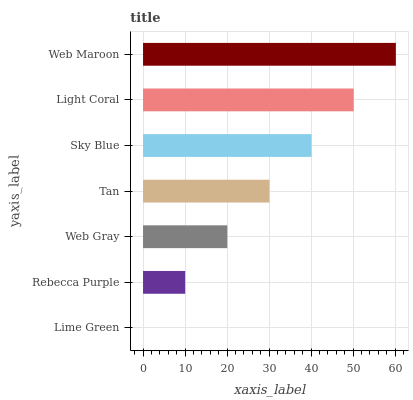Is Lime Green the minimum?
Answer yes or no. Yes. Is Web Maroon the maximum?
Answer yes or no. Yes. Is Rebecca Purple the minimum?
Answer yes or no. No. Is Rebecca Purple the maximum?
Answer yes or no. No. Is Rebecca Purple greater than Lime Green?
Answer yes or no. Yes. Is Lime Green less than Rebecca Purple?
Answer yes or no. Yes. Is Lime Green greater than Rebecca Purple?
Answer yes or no. No. Is Rebecca Purple less than Lime Green?
Answer yes or no. No. Is Tan the high median?
Answer yes or no. Yes. Is Tan the low median?
Answer yes or no. Yes. Is Web Maroon the high median?
Answer yes or no. No. Is Web Maroon the low median?
Answer yes or no. No. 